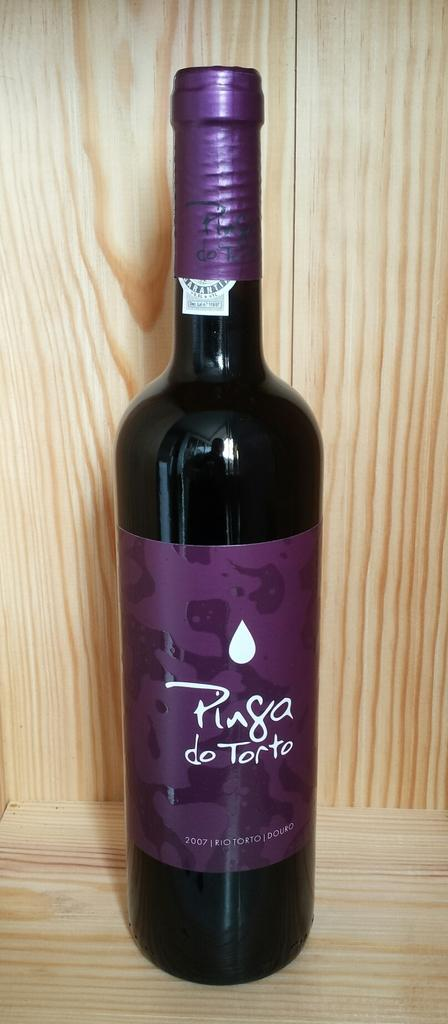<image>
Summarize the visual content of the image. A dark bottle of wine has a purple label that says "Pinga do Torto". 